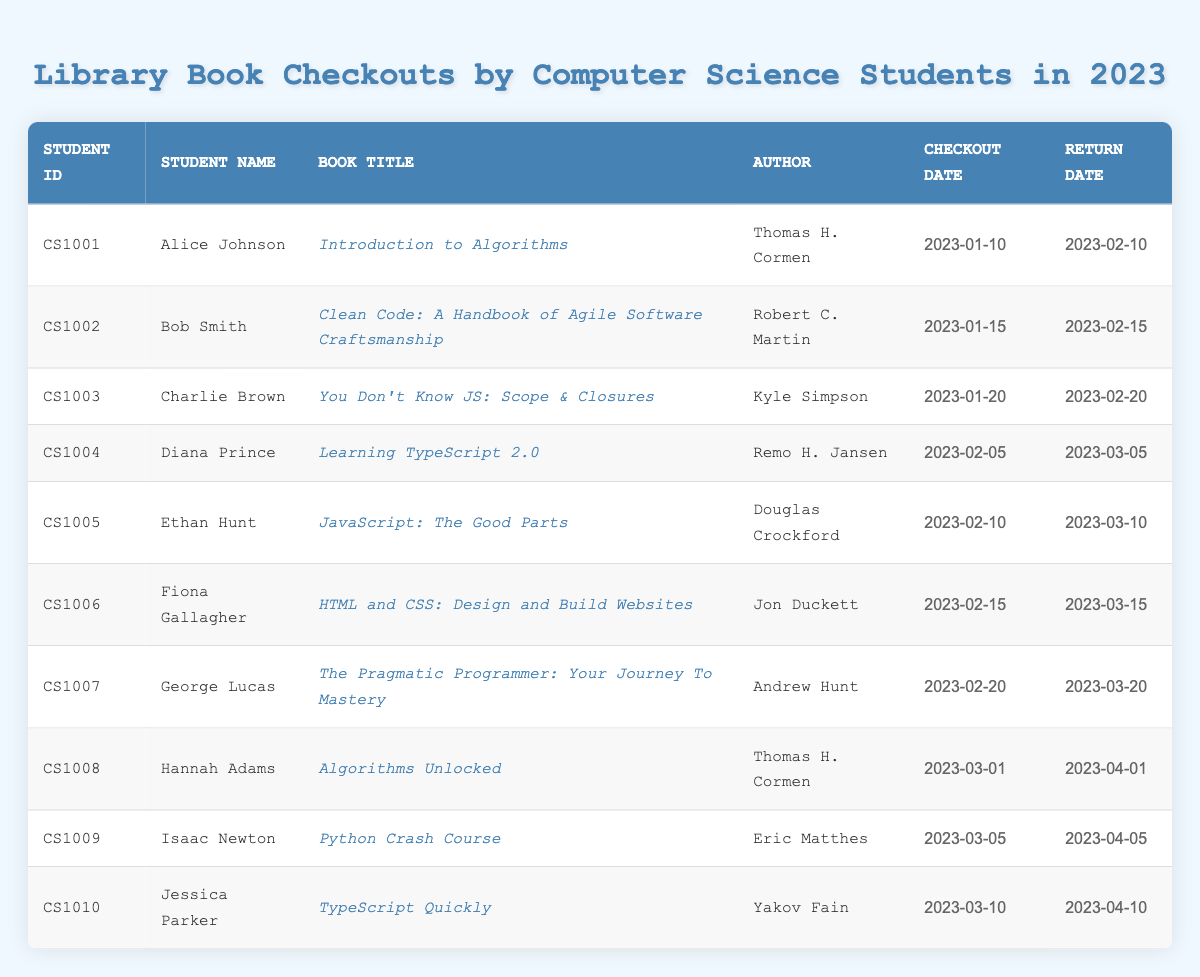What is the title of the book checked out by Alice Johnson? According to the table, Alice Johnson has checked out the book titled "Introduction to Algorithms".
Answer: Introduction to Algorithms Who is the author of "Clean Code: A Handbook of Agile Software Craftsmanship"? The table indicates that the author of the book "Clean Code: A Handbook of Agile Software Craftsmanship" is Robert C. Martin.
Answer: Robert C. Martin How many books were checked out in total? By counting the number of rows in the table, we find that there are 10 entries. This means that a total of 10 books were checked out.
Answer: 10 Did Fiona Gallagher return her book on time? The table shows that Fiona Gallagher checked out her book on February 15, 2023, and the return date is March 15, 2023, which is exactly one month later. Therefore, she returned the book on time.
Answer: Yes What is the average return date of all the books checked out? The return dates listed are: February 10, February 15, February 20, March 5, March 10, March 15, March 20, April 1, April 5, and April 10. To find the average, we convert these dates to numerical formats, add the numerical representations for date and month, and divide the total by 10. The average date comes out to be approximately March 10.
Answer: March 10 Which student checked out the book "TypeScript Quickly"? The table shows that Jessica Parker is the student who checked out the book "TypeScript Quickly".
Answer: Jessica Parker How many students checked out books in February? There are six students with checkout dates in February: Alice Johnson, Bob Smith, Diana Prince, Ethan Hunt, Fiona Gallagher, and George Lucas. Therefore, a total of 6 students checked out books in February.
Answer: 6 Is "Learning TypeScript 2.0" the only book checked out in February? Checking the table shows that there are several other books checked out in February, including titles by Alice Johnson, Bob Smith, Ethan Hunt, and others. Hence, it is not the only book checked out in that month.
Answer: No Which book was returned on March 20? Looking at the return dates, the book returned on March 20 was checked out by George Lucas. The corresponding book title is "The Pragmatic Programmer: Your Journey To Mastery".
Answer: The Pragmatic Programmer: Your Journey To Mastery 